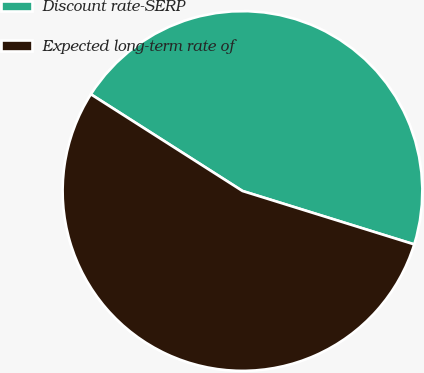Convert chart to OTSL. <chart><loc_0><loc_0><loc_500><loc_500><pie_chart><fcel>Discount rate-SERP<fcel>Expected long-term rate of<nl><fcel>45.76%<fcel>54.24%<nl></chart> 